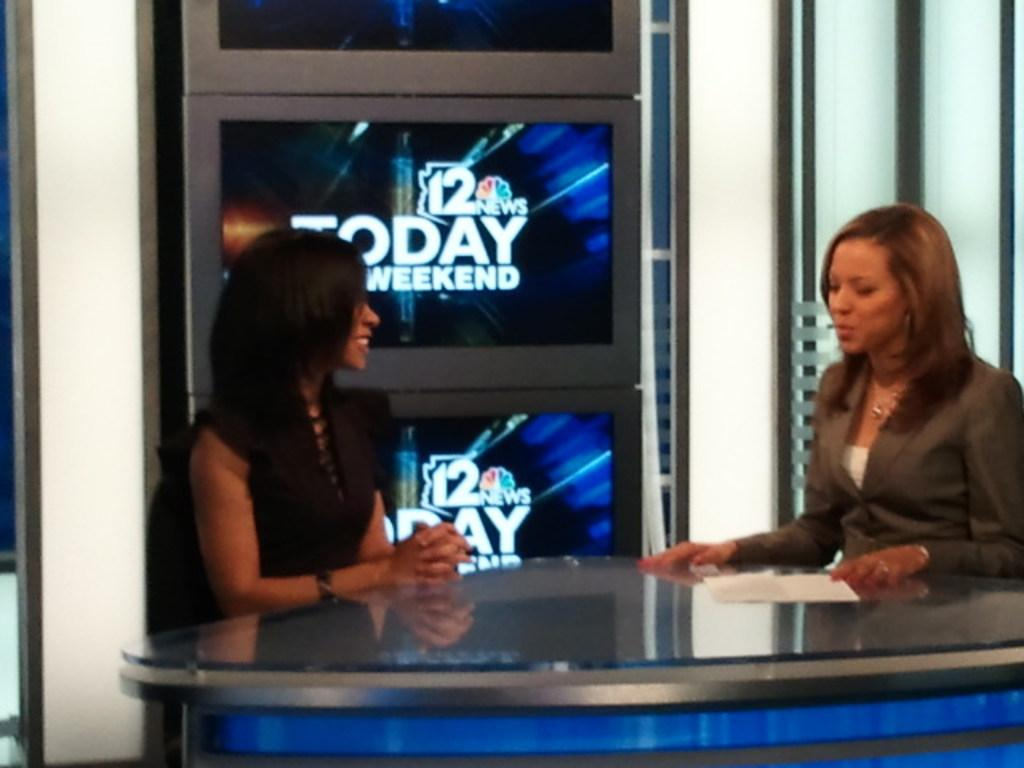How many people are present in the image? There are two women sitting in the image. What is in front of the women? There is a table in front of the women. What is on the table? There is a paper on the table. What can be seen on the wall behind the women? There are screens attached to the wall. What is displayed on the screens? Text is displayed on the screens. What is the limit of the society in the image? There is no reference to a society or any limits in the image; it features two women sitting at a table with a paper and screens displaying text. 